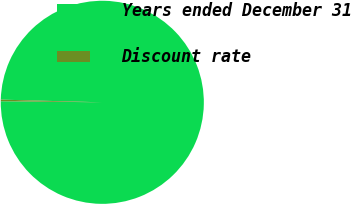Convert chart. <chart><loc_0><loc_0><loc_500><loc_500><pie_chart><fcel>Years ended December 31<fcel>Discount rate<nl><fcel>99.75%<fcel>0.25%<nl></chart> 